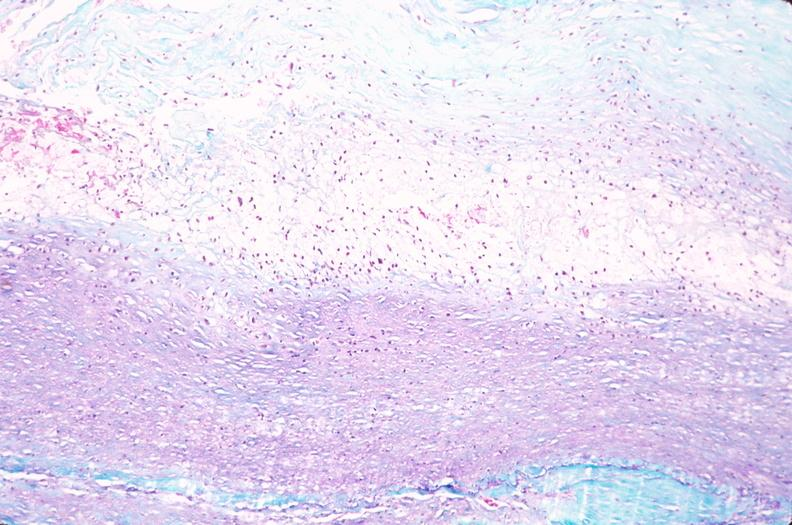s cardiovascular present?
Answer the question using a single word or phrase. Yes 